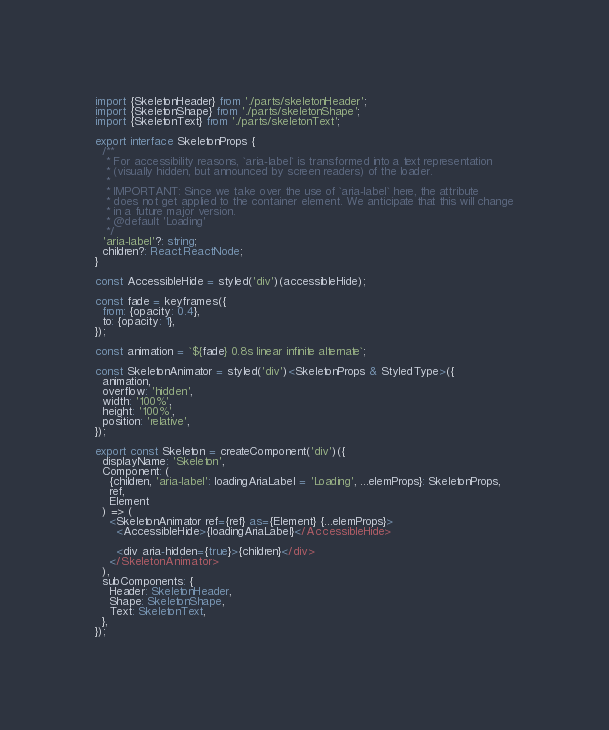<code> <loc_0><loc_0><loc_500><loc_500><_TypeScript_>import {SkeletonHeader} from './parts/skeletonHeader';
import {SkeletonShape} from './parts/skeletonShape';
import {SkeletonText} from './parts/skeletonText';

export interface SkeletonProps {
  /**
   * For accessibility reasons, `aria-label` is transformed into a text representation
   * (visually hidden, but announced by screen readers) of the loader.
   *
   * IMPORTANT: Since we take over the use of `aria-label` here, the attribute
   * does not get applied to the container element. We anticipate that this will change
   * in a future major version.
   * @default 'Loading'
   */
  'aria-label'?: string;
  children?: React.ReactNode;
}

const AccessibleHide = styled('div')(accessibleHide);

const fade = keyframes({
  from: {opacity: 0.4},
  to: {opacity: 1},
});

const animation = `${fade} 0.8s linear infinite alternate`;

const SkeletonAnimator = styled('div')<SkeletonProps & StyledType>({
  animation,
  overflow: 'hidden',
  width: '100%',
  height: '100%',
  position: 'relative',
});

export const Skeleton = createComponent('div')({
  displayName: 'Skeleton',
  Component: (
    {children, 'aria-label': loadingAriaLabel = 'Loading', ...elemProps}: SkeletonProps,
    ref,
    Element
  ) => (
    <SkeletonAnimator ref={ref} as={Element} {...elemProps}>
      <AccessibleHide>{loadingAriaLabel}</AccessibleHide>

      <div aria-hidden={true}>{children}</div>
    </SkeletonAnimator>
  ),
  subComponents: {
    Header: SkeletonHeader,
    Shape: SkeletonShape,
    Text: SkeletonText,
  },
});
</code> 